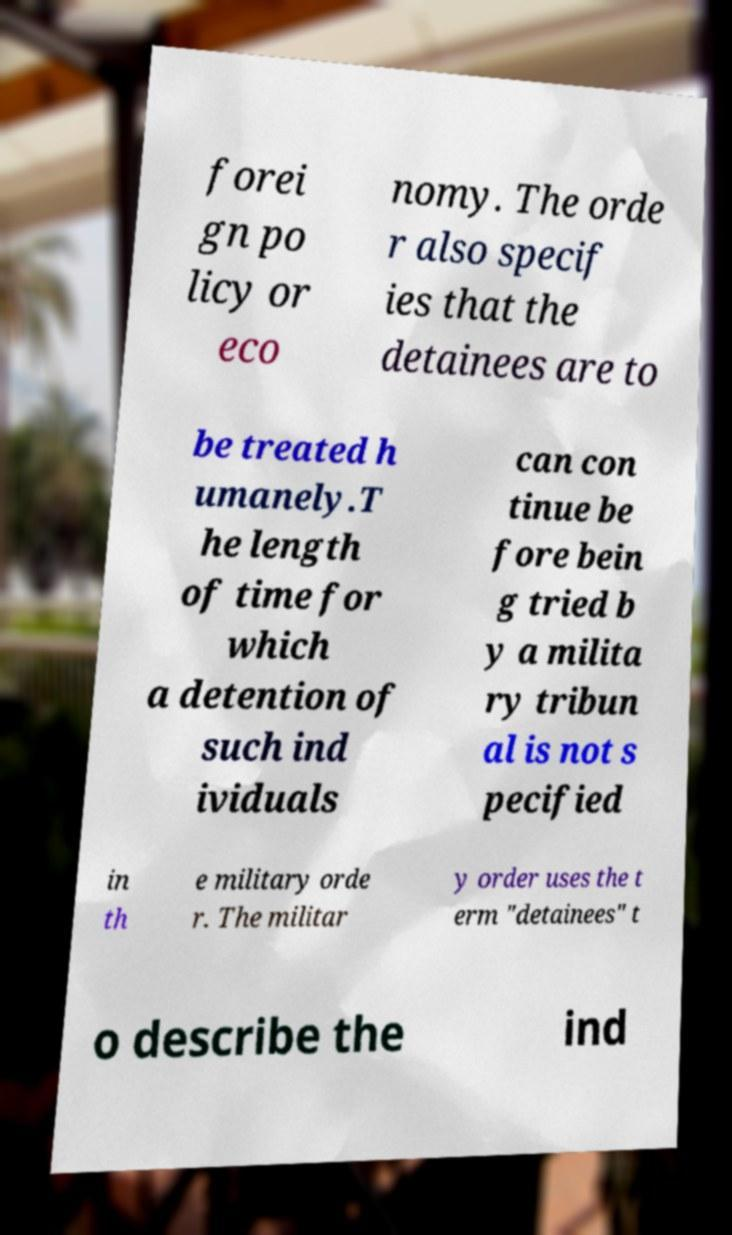Please identify and transcribe the text found in this image. forei gn po licy or eco nomy. The orde r also specif ies that the detainees are to be treated h umanely.T he length of time for which a detention of such ind ividuals can con tinue be fore bein g tried b y a milita ry tribun al is not s pecified in th e military orde r. The militar y order uses the t erm "detainees" t o describe the ind 